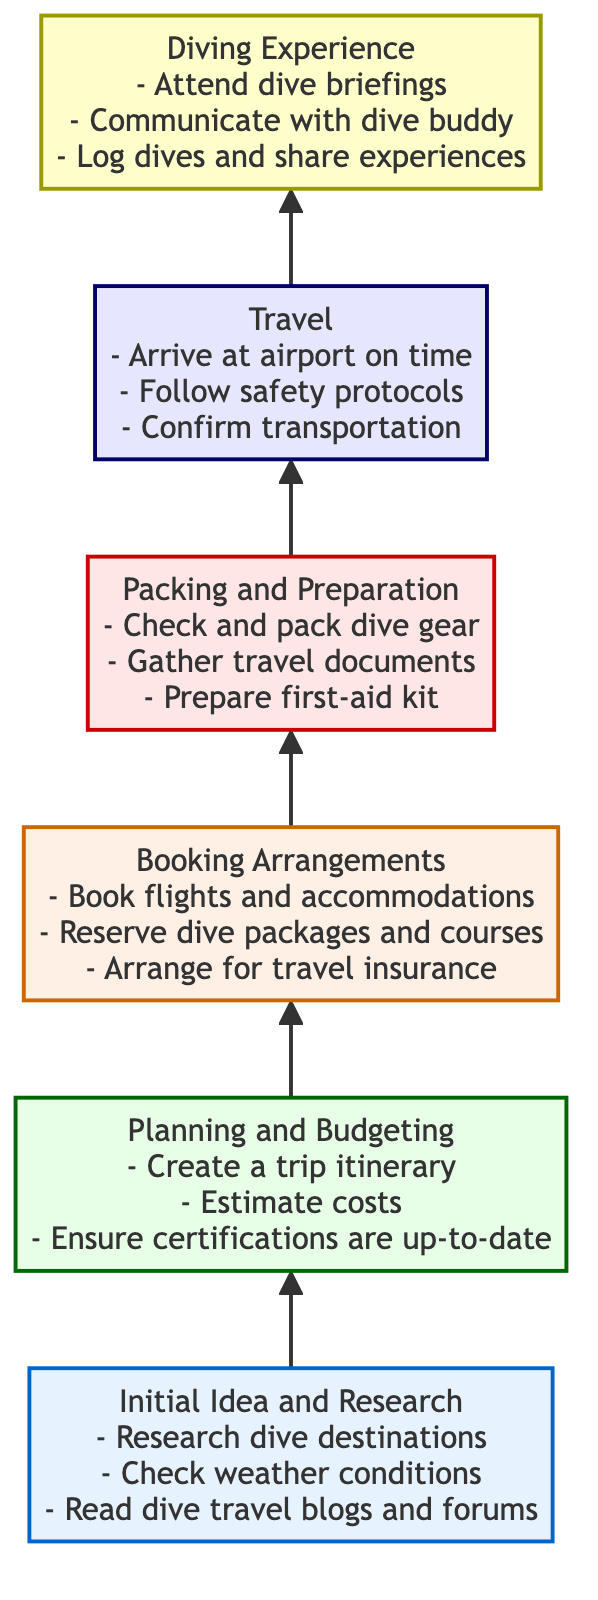What is the first step in the dive trip planning process? The diagram starts with "Initial Idea and Research" as the first step, indicating that this is where you begin your dive trip planning.
Answer: Initial Idea and Research How many actionable items are listed under "Packing and Preparation"? Under the "Packing and Preparation" node, there are three actionable items mentioned, which are to check and pack dive gear, gather travel documents, and prepare a first-aid kit.
Answer: 3 Which step comes after "Booking Arrangements"? The flowchart shows that "Packing and Preparation" follows "Booking Arrangements," indicating that after you finalize bookings, you prepare for the trip.
Answer: Packing and Preparation What needs to be done to ensure certifications are up-to-date? The "Planning and Budgeting" node specifically mentions ensuring all certifications are up-to-date as a necessary step before moving forward with booking arrangements.
Answer: Ensure certifications are up-to-date What is the last step before the diving experience begins? The final step that precedes the "Diving Experience" is "Travel," which indicates that all preparations must be complete before traveling to the dive destination.
Answer: Travel How does the flow of the diagram progress from "Initial Idea and Research" to "Diving Experience"? The flow of the diagram indicates a sequential process where you start from "Initial Idea and Research," proceed to planning, then booking, followed by packing, traveling, and finally, arriving at the "Diving Experience." Each step connects logically and leads to the next.
Answer: Sequentially through planning, booking, packing, and traveling What two actions are included in the "Travel" section? The "Travel" node lists three actionable items: arriving at the airport on time, following travel safety protocols, and confirming transportation arrangements. However, to answer the question specifically, two of them can be mentioned: arriving at the airport on time and following safety protocols.
Answer: Arrive at airport on time, Follow safety protocols What is a major focus during the "Diving Experience"? A major focus during the "Diving Experience" is to attend dive briefings, communicate with your dive buddy, and log your dives and share experiences. The importance of these actions is emphasized as part of ensuring a safe and enjoyable experience underwater.
Answer: Attend dive briefings, Communicate with dive buddy, Log dives 